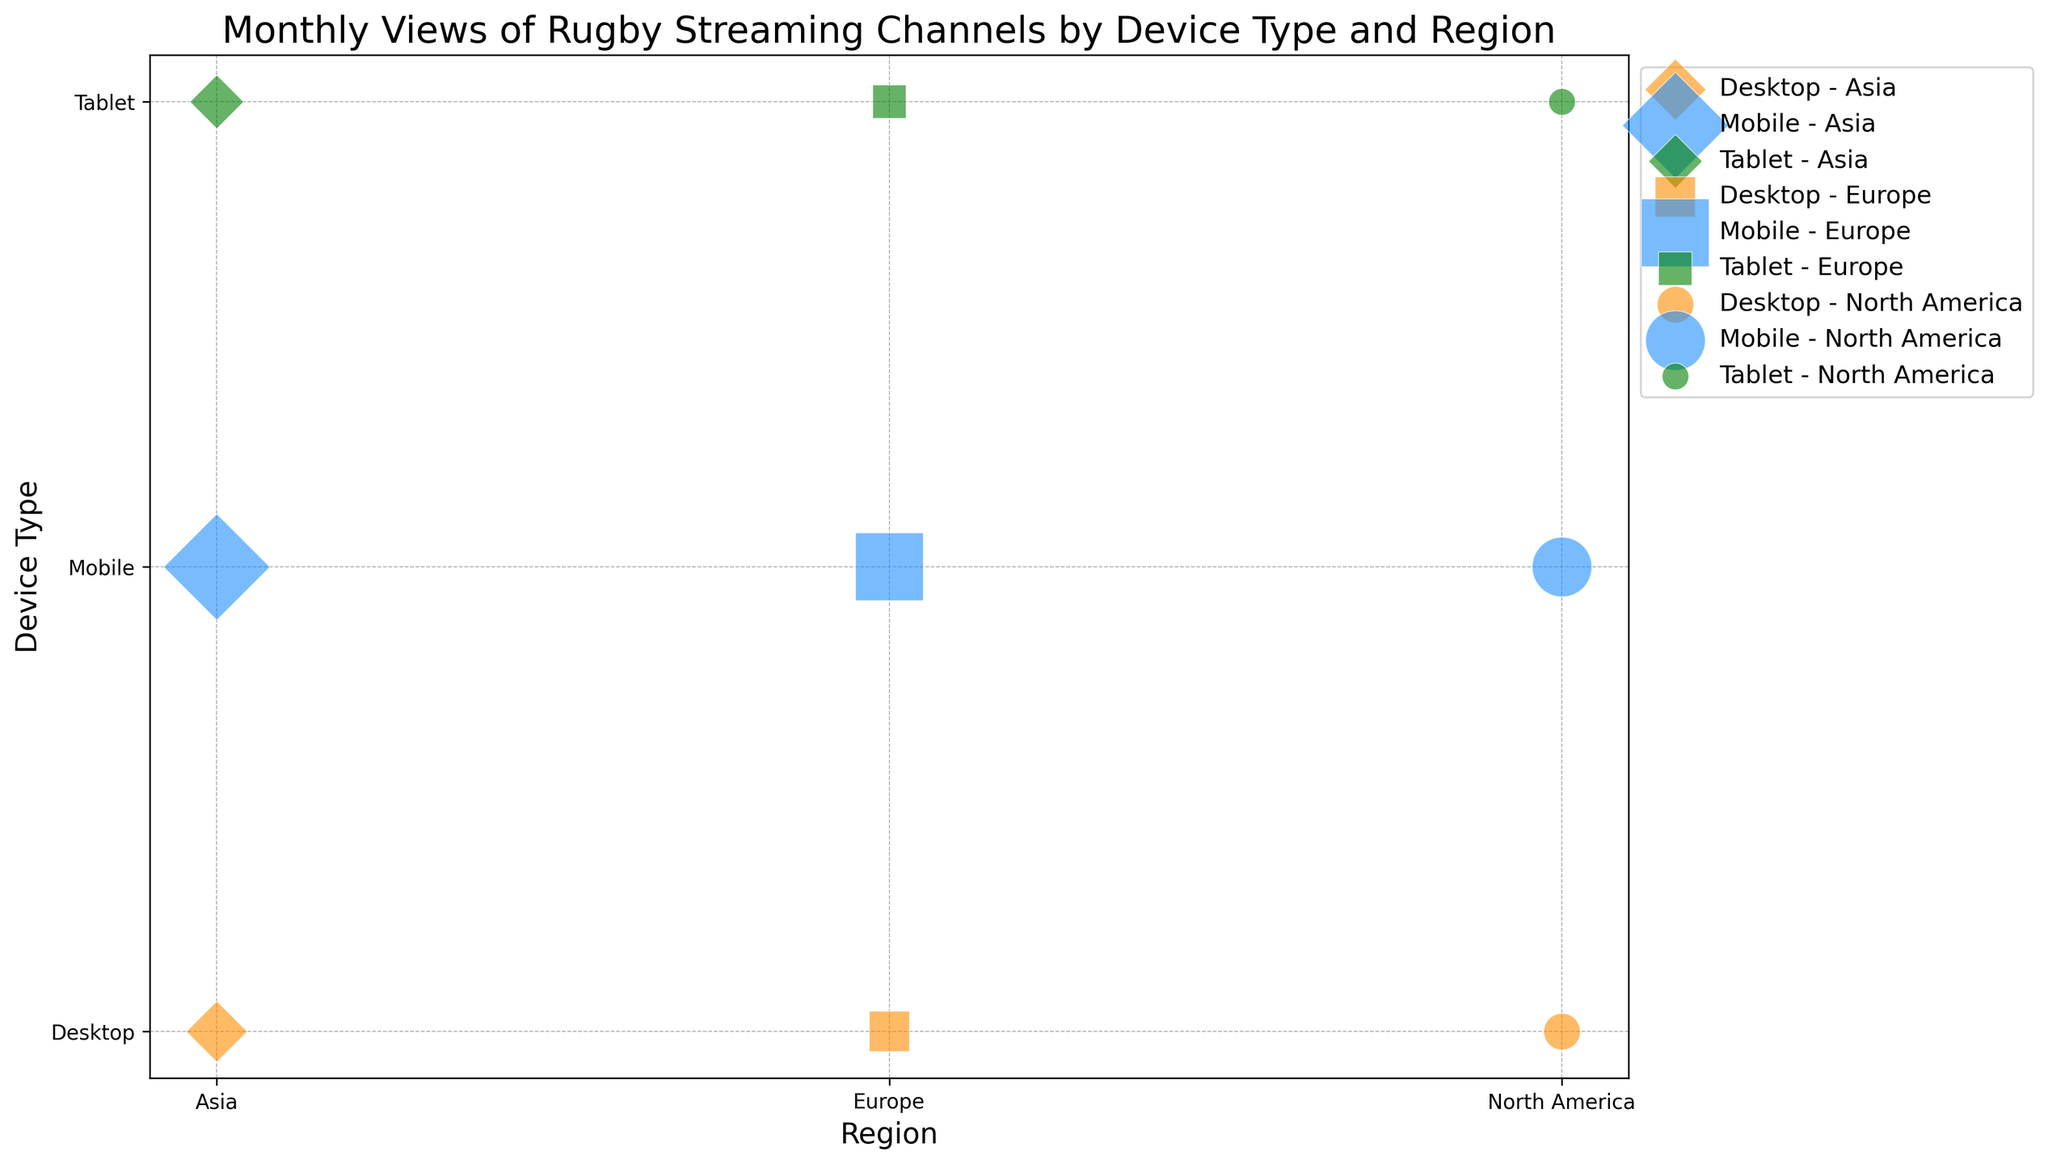What region has the highest number of views for mobile devices? To find the region with the highest number of views for mobile devices, look for the data points represented by blue markers (indicating mobile devices). Compare the sizes of these markers across different regions. The largest marker size represents the highest number of views.
Answer: Asia How do the combined views for desktop devices compare between North America and Europe? First, identify the orange markers representing desktop devices in North America and Europe. Sum the sizes of these markers (which represent the total views). Compare the summed values to determine which region has more views.
Answer: Europe Which region has the smallest number of views for tablet devices across all months? Identify the green markers representing tablet devices. Compare the sizes of these markers across different regions. The smallest marker size will indicate the region with the lowest views for tablet devices.
Answer: North America What is the total number of views for mobile devices in Europe across all months? Identify the blue markers corresponding to mobile devices in Europe. Add up the sizes of these markers (each size represents the number of views converted to a scaled-down marker size).
Answer: 1,100,000 Does Asia have more views from desktop devices or tablet devices? Identify the orange markers for desktop devices and green markers for tablet devices in Asia. Compare the sizes of these markers to see which one is bigger, indicating more views.
Answer: Desktop devices Compare the monthly views of rugby streaming channels for mobile devices in North America and Asia. Look at the blue markers which represent mobile devices in North America and Asia. Compare the sizes of these markers for each month to answer the question monthly. E.g., in the month of January, compare the marker sizes for North America and Asia. Repeat for other months.
Answer: Asia consistently has higher monthly views for mobile devices Across all regions, which device type has the highest number of total views? Look at the overall sizes (bubbles) of each color representing mobile (blue), desktop (orange), and tablet (green) devices. The device type with the biggest total bubble size represents the highest number of total views.
Answer: Mobile What is the average number of views for desktop devices in Asia per month? Sum the total number of views for desktop devices in Asia (for all months) and divide by the number of months. Total views for desktop devices in Asia = 85,000 + 87,000 + 89,000 + 91,000 + 93,000 = 445,000. Divide by 5 (the number of months).
Answer: 89,000 Which combination of device type and region has the highest single monthly view count? Identify the single biggest bubble among all markers, which indicates the highest monthly view count. Check the corresponding device type and region for the biggest bubble size.
Answer: Mobile - Asia 